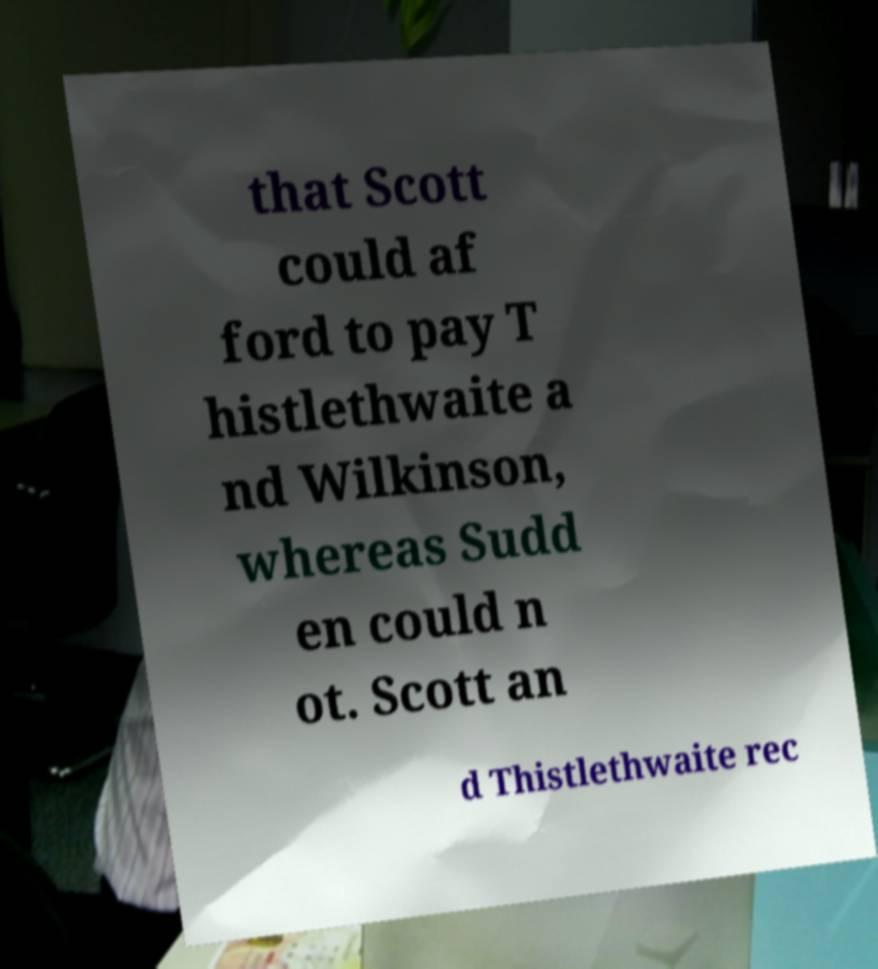Could you assist in decoding the text presented in this image and type it out clearly? that Scott could af ford to pay T histlethwaite a nd Wilkinson, whereas Sudd en could n ot. Scott an d Thistlethwaite rec 